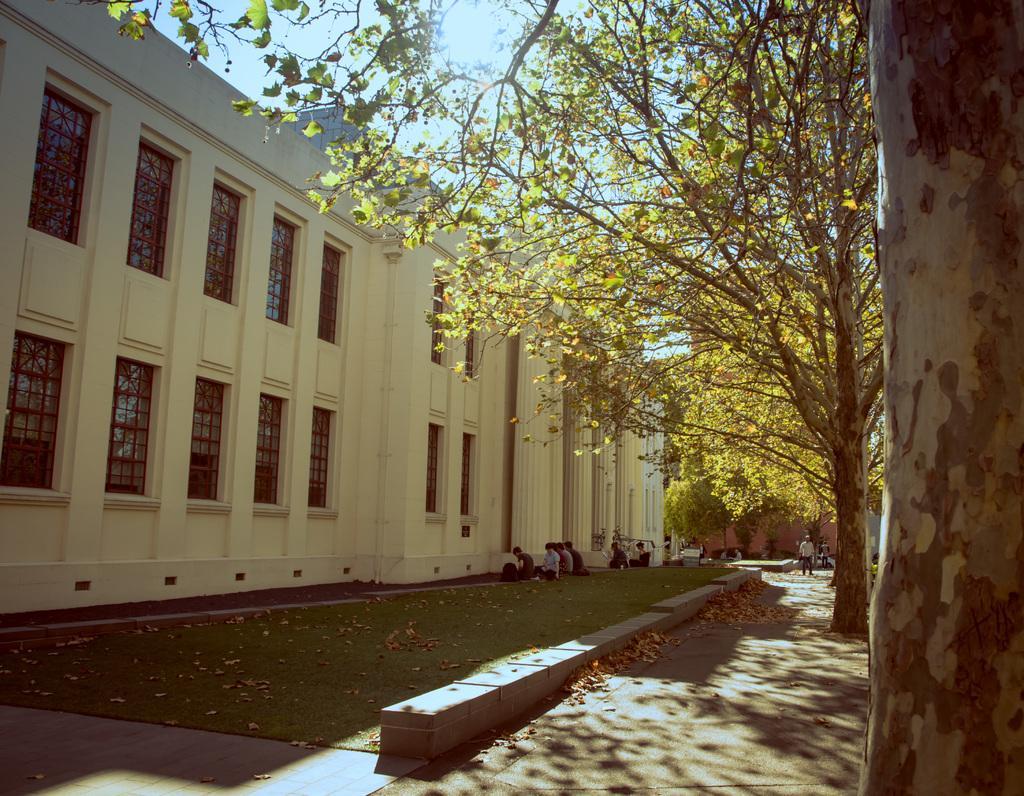In one or two sentences, can you explain what this image depicts? In this picture, we can see a few people, and we can see the path and some dry leaves, we can see ground trees, buildings with windows, and we can see the sky. 